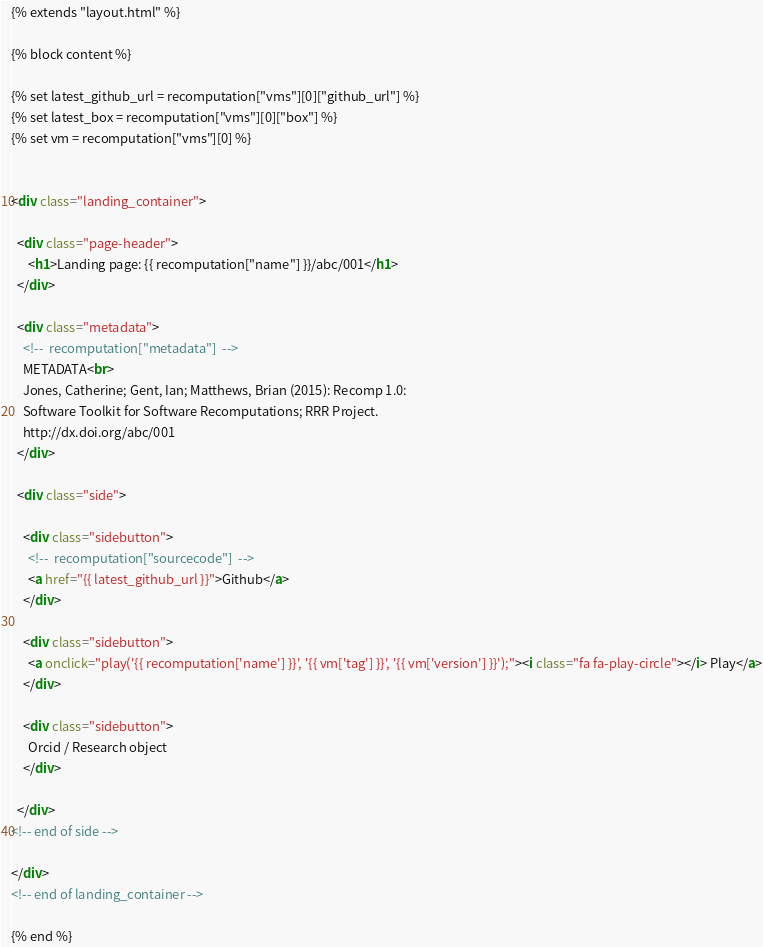<code> <loc_0><loc_0><loc_500><loc_500><_HTML_>{% extends "layout.html" %}

{% block content %}

{% set latest_github_url = recomputation["vms"][0]["github_url"] %}
{% set latest_box = recomputation["vms"][0]["box"] %}
{% set vm = recomputation["vms"][0] %}


<div class="landing_container">

  <div class="page-header">
      <h1>Landing page: {{ recomputation["name"] }}/abc/001</h1>
  </div>

  <div class="metadata">
    <!--  recomputation["metadata"]  -->
    METADATA<br>
    Jones, Catherine; Gent, Ian; Matthews, Brian (2015): Recomp 1.0:
    Software Toolkit for Software Recomputations; RRR Project.
    http://dx.doi.org/abc/001
  </div>

  <div class="side">

    <div class="sidebutton">
      <!--  recomputation["sourcecode"]  -->
      <a href="{{ latest_github_url }}">Github</a>
    </div>

    <div class="sidebutton">
      <a onclick="play('{{ recomputation['name'] }}', '{{ vm['tag'] }}', '{{ vm['version'] }}');"><i class="fa fa-play-circle"></i> Play</a>
    </div>

    <div class="sidebutton">
      Orcid / Research object
    </div>

  </div>
<!-- end of side -->

</div>
<!-- end of landing_container -->

{% end %}
</code> 